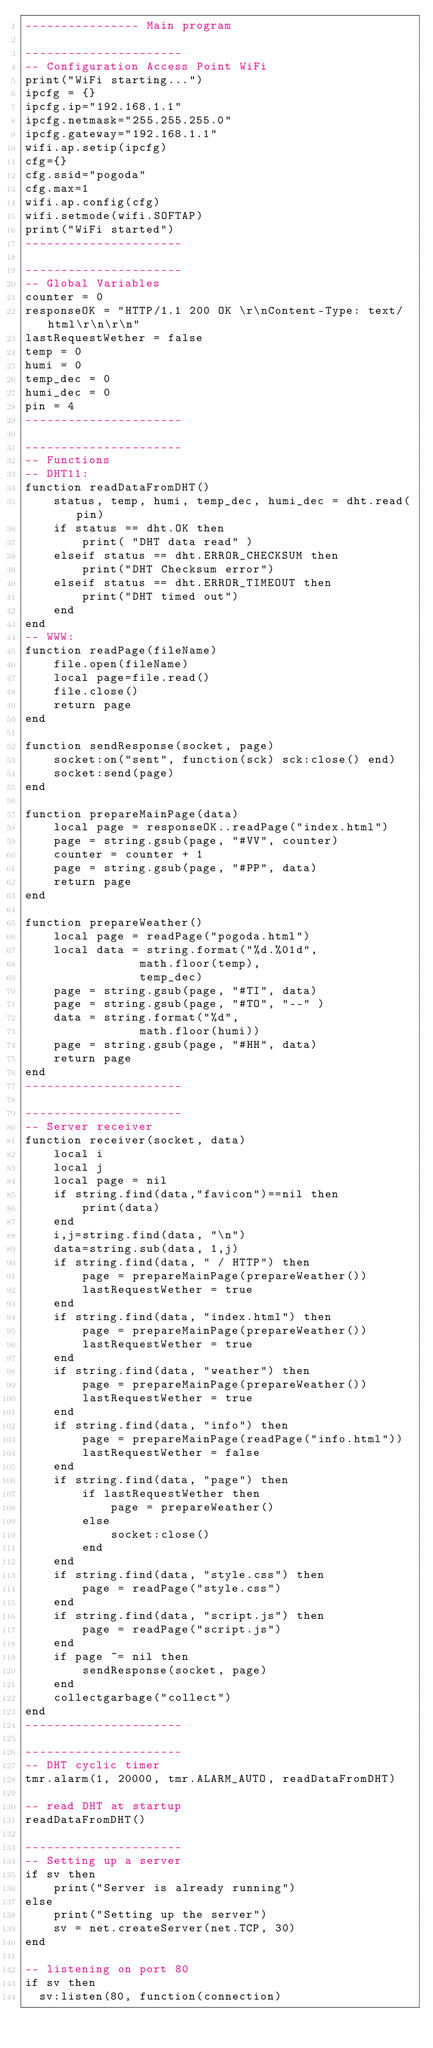<code> <loc_0><loc_0><loc_500><loc_500><_Lua_>---------------- Main program

----------------------
-- Configuration Access Point WiFi
print("WiFi starting...")
ipcfg = {}
ipcfg.ip="192.168.1.1"
ipcfg.netmask="255.255.255.0"
ipcfg.gateway="192.168.1.1"
wifi.ap.setip(ipcfg) 
cfg={}
cfg.ssid="pogoda"
cfg.max=1
wifi.ap.config(cfg) 
wifi.setmode(wifi.SOFTAP)
print("WiFi started")
----------------------

----------------------
-- Global Variables
counter = 0
responseOK = "HTTP/1.1 200 OK \r\nContent-Type: text/html\r\n\r\n"
lastRequestWether = false
temp = 0
humi = 0
temp_dec = 0
humi_dec = 0
pin = 4
----------------------

----------------------
-- Functions
-- DHT11:
function readDataFromDHT()
	status, temp, humi, temp_dec, humi_dec = dht.read(pin)
	if status == dht.OK then
		print( "DHT data read" )
	elseif status == dht.ERROR_CHECKSUM then
		print("DHT Checksum error")
	elseif status == dht.ERROR_TIMEOUT then
		print("DHT timed out")
	end
end
-- WWW:
function readPage(fileName)
    file.open(fileName)
    local page=file.read()
    file.close()
	return page
end

function sendResponse(socket, page)
	socket:on("sent", function(sck) sck:close() end)    
	socket:send(page)
end

function prepareMainPage(data)
    local page = responseOK..readPage("index.html")
    page = string.gsub(page, "#VV", counter)
    counter = counter + 1
    page = string.gsub(page, "#PP", data)
    return page
end

function prepareWeather()
    local page = readPage("pogoda.html")
	local data = string.format("%d.%01d",
      			math.floor(temp),
      			temp_dec)
    page = string.gsub(page, "#TI", data)
    page = string.gsub(page, "#TO", "--" )
	data = string.format("%d",
      			math.floor(humi))
    page = string.gsub(page, "#HH", data)
    return page
end
----------------------

----------------------
-- Server receiver
function receiver(socket, data)
    local i
    local j
	local page = nil
    if string.find(data,"favicon")==nil then    
        print(data)
    end
    i,j=string.find(data, "\n")
    data=string.sub(data, 1,j) 
    if string.find(data, " / HTTP") then
		page = prepareMainPage(prepareWeather())
		lastRequestWether = true
    end     
    if string.find(data, "index.html") then
		page = prepareMainPage(prepareWeather())
		lastRequestWether = true
    end   
    if string.find(data, "weather") then
		page = prepareMainPage(prepareWeather())
		lastRequestWether = true
    end
    if string.find(data, "info") then
		page = prepareMainPage(readPage("info.html"))
		lastRequestWether = false
    end
	if string.find(data, "page") then
		if lastRequestWether then
		    page = prepareWeather()
		else
		    socket:close()
		end
    end
	if string.find(data, "style.css") then
		page = readPage("style.css")
    end
	if string.find(data, "script.js") then
		page = readPage("script.js")
    end
    if page ~= nil then
	    sendResponse(socket, page)
    end
    collectgarbage("collect")       
end
----------------------

----------------------
-- DHT cyclic timer
tmr.alarm(1, 20000, tmr.ALARM_AUTO, readDataFromDHT) 

-- read DHT at startup
readDataFromDHT()

----------------------
-- Setting up a server
if sv then                
    print("Server is already running") 
else                      
    print("Setting up the server")
    sv = net.createServer(net.TCP, 30)
end

-- listening on port 80
if sv then
  sv:listen(80, function(connection)</code> 